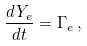<formula> <loc_0><loc_0><loc_500><loc_500>\frac { d Y _ { e } } { d t } = \Gamma _ { e } \, ,</formula> 